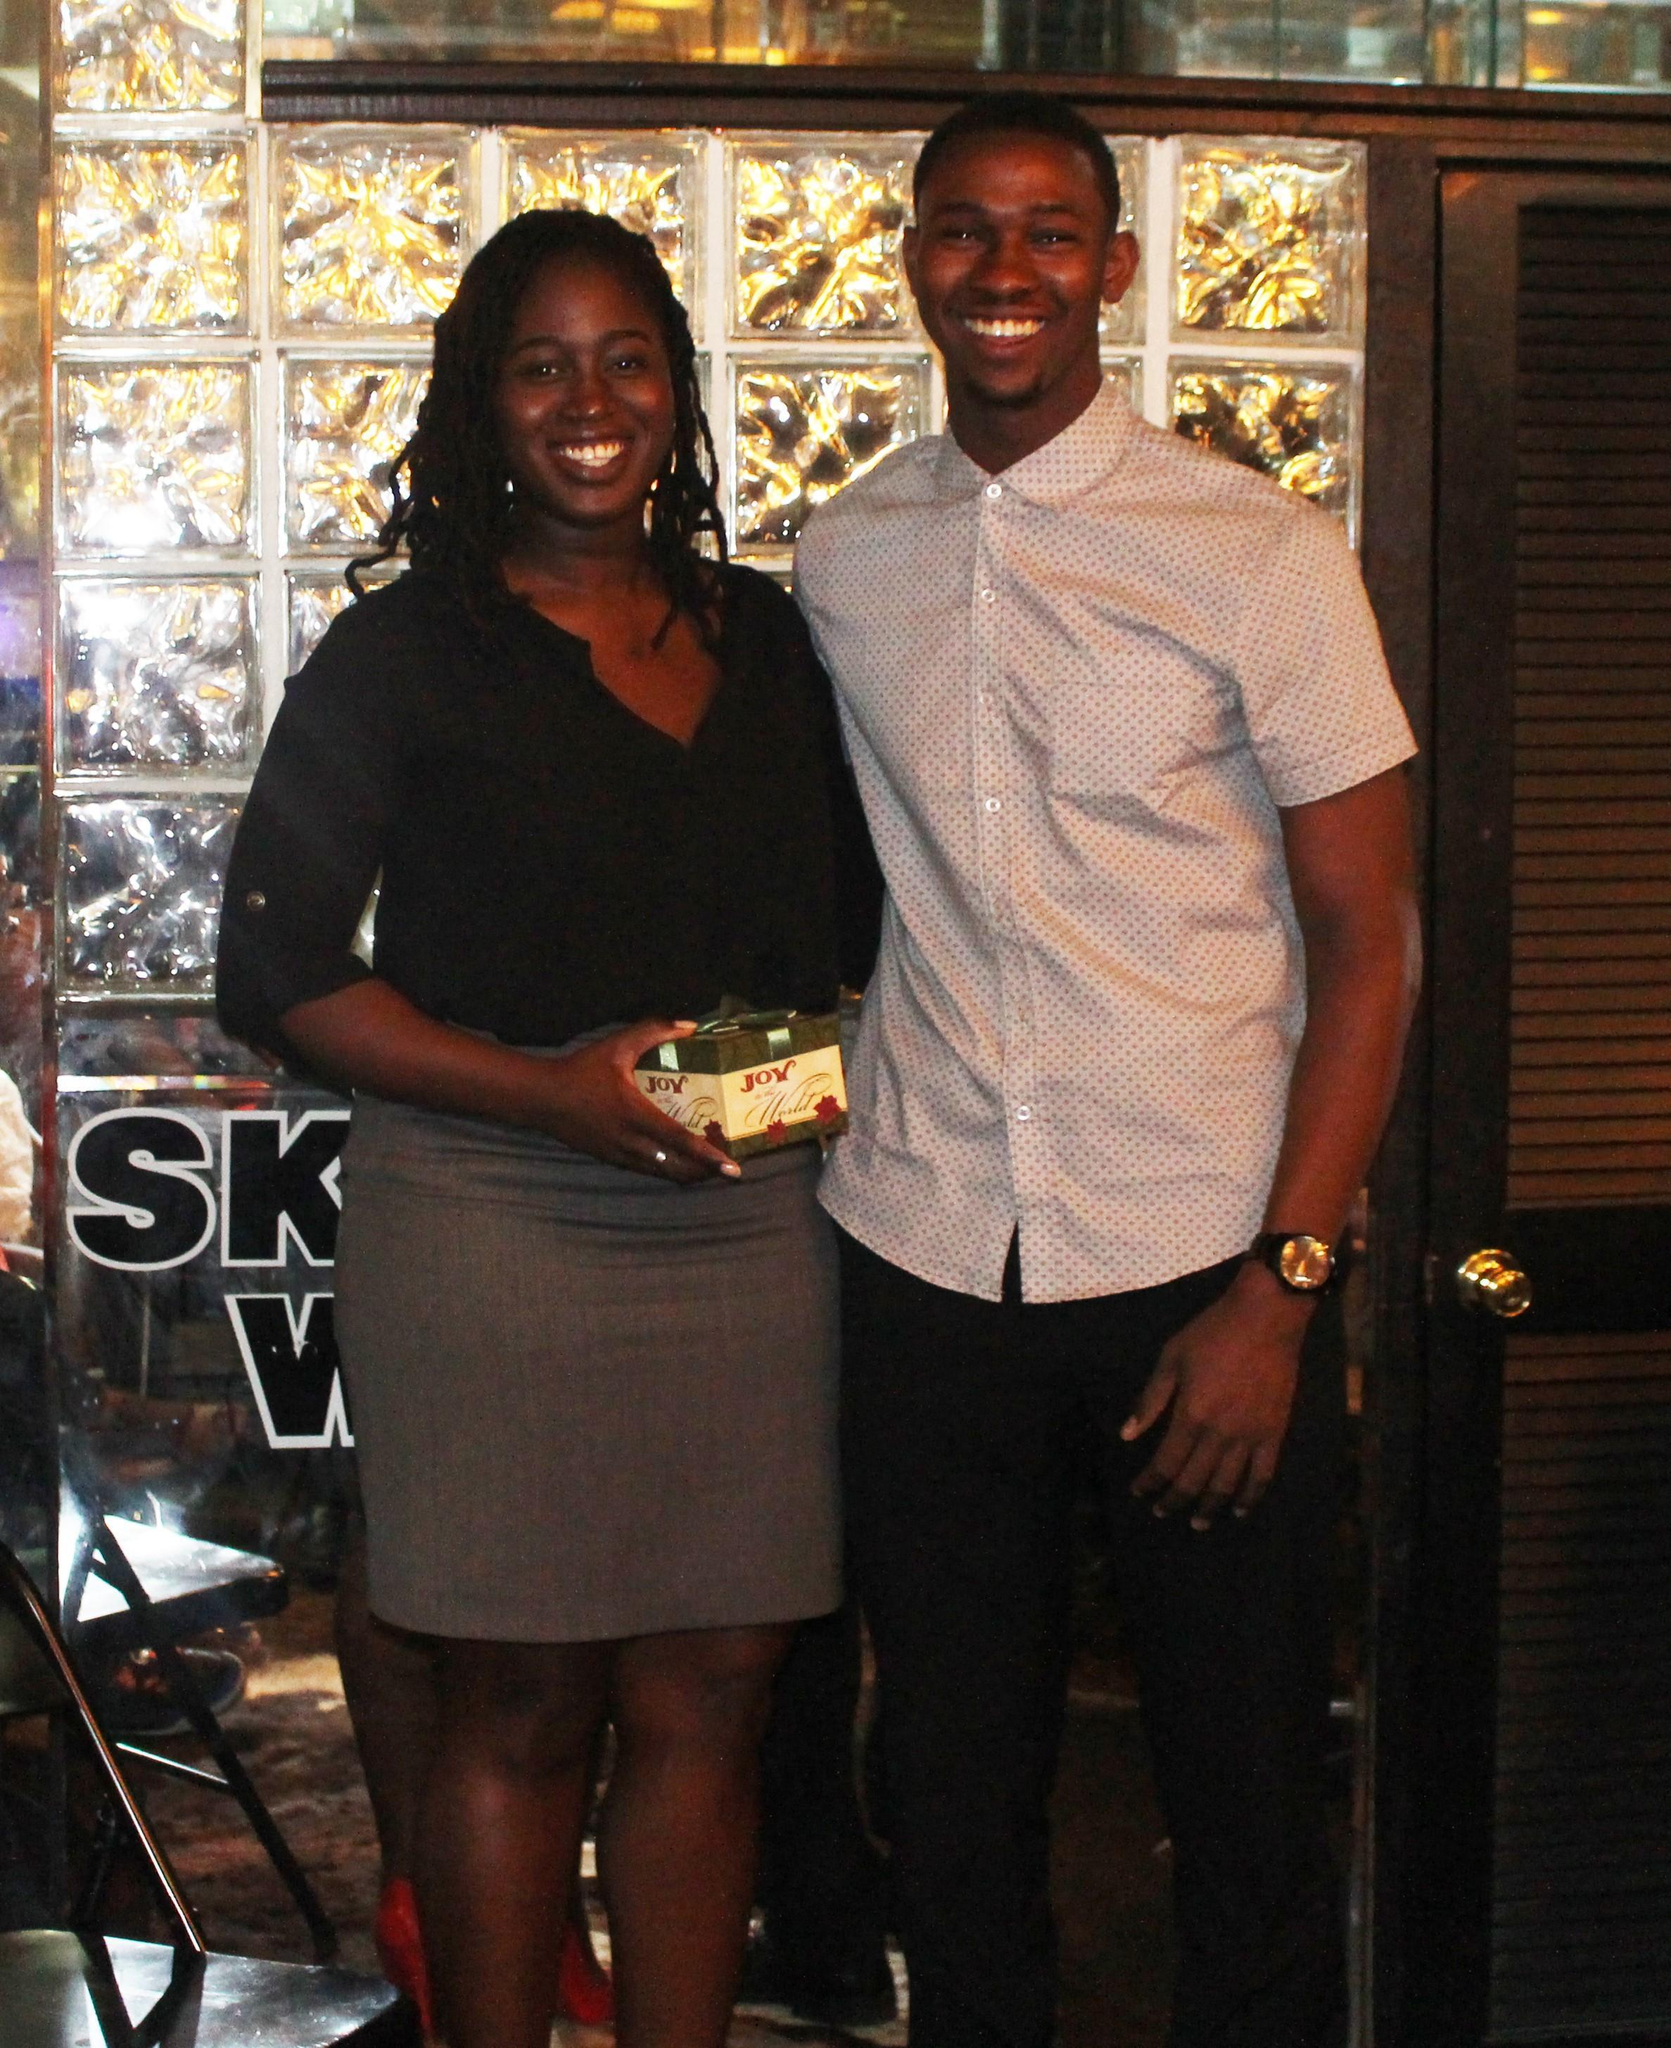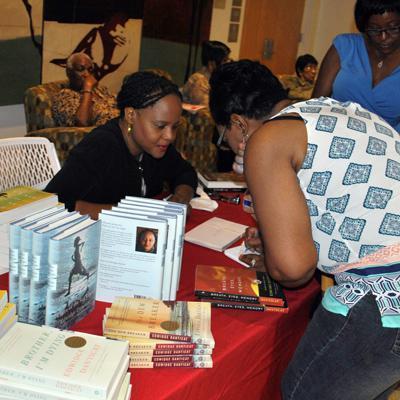The first image is the image on the left, the second image is the image on the right. Evaluate the accuracy of this statement regarding the images: "There is at least five people in a barber shop.". Is it true? Answer yes or no. No. The first image is the image on the left, the second image is the image on the right. Analyze the images presented: Is the assertion "All the people are African Americans." valid? Answer yes or no. Yes. 